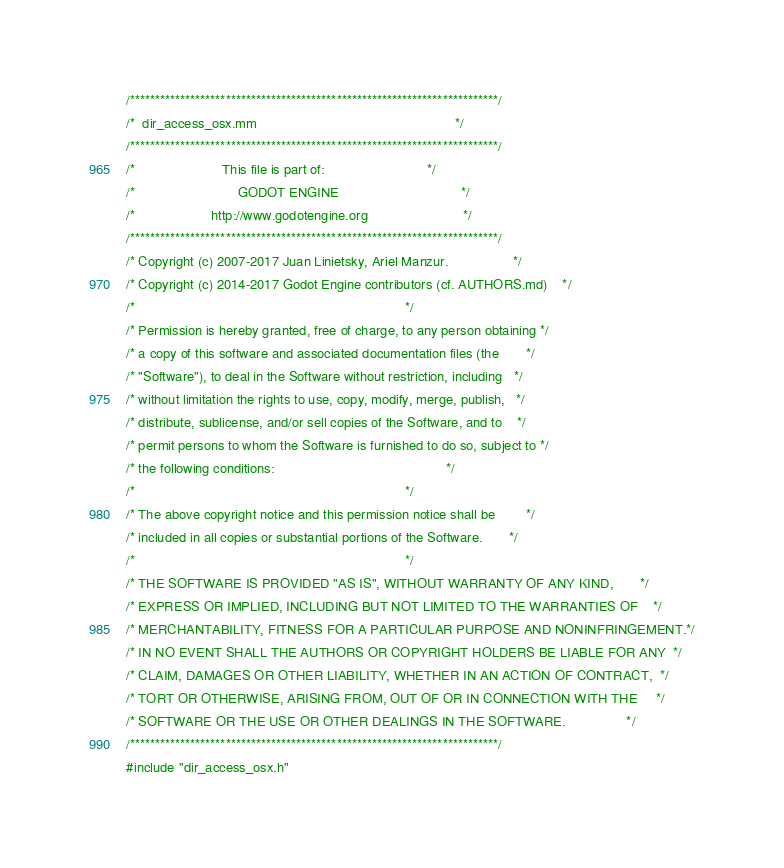Convert code to text. <code><loc_0><loc_0><loc_500><loc_500><_ObjectiveC_>/*************************************************************************/
/*  dir_access_osx.mm                                                    */
/*************************************************************************/
/*                       This file is part of:                           */
/*                           GODOT ENGINE                                */
/*                    http://www.godotengine.org                         */
/*************************************************************************/
/* Copyright (c) 2007-2017 Juan Linietsky, Ariel Manzur.                 */
/* Copyright (c) 2014-2017 Godot Engine contributors (cf. AUTHORS.md)    */
/*                                                                       */
/* Permission is hereby granted, free of charge, to any person obtaining */
/* a copy of this software and associated documentation files (the       */
/* "Software"), to deal in the Software without restriction, including   */
/* without limitation the rights to use, copy, modify, merge, publish,   */
/* distribute, sublicense, and/or sell copies of the Software, and to    */
/* permit persons to whom the Software is furnished to do so, subject to */
/* the following conditions:                                             */
/*                                                                       */
/* The above copyright notice and this permission notice shall be        */
/* included in all copies or substantial portions of the Software.       */
/*                                                                       */
/* THE SOFTWARE IS PROVIDED "AS IS", WITHOUT WARRANTY OF ANY KIND,       */
/* EXPRESS OR IMPLIED, INCLUDING BUT NOT LIMITED TO THE WARRANTIES OF    */
/* MERCHANTABILITY, FITNESS FOR A PARTICULAR PURPOSE AND NONINFRINGEMENT.*/
/* IN NO EVENT SHALL THE AUTHORS OR COPYRIGHT HOLDERS BE LIABLE FOR ANY  */
/* CLAIM, DAMAGES OR OTHER LIABILITY, WHETHER IN AN ACTION OF CONTRACT,  */
/* TORT OR OTHERWISE, ARISING FROM, OUT OF OR IN CONNECTION WITH THE     */
/* SOFTWARE OR THE USE OR OTHER DEALINGS IN THE SOFTWARE.                */
/*************************************************************************/
#include "dir_access_osx.h"
</code> 